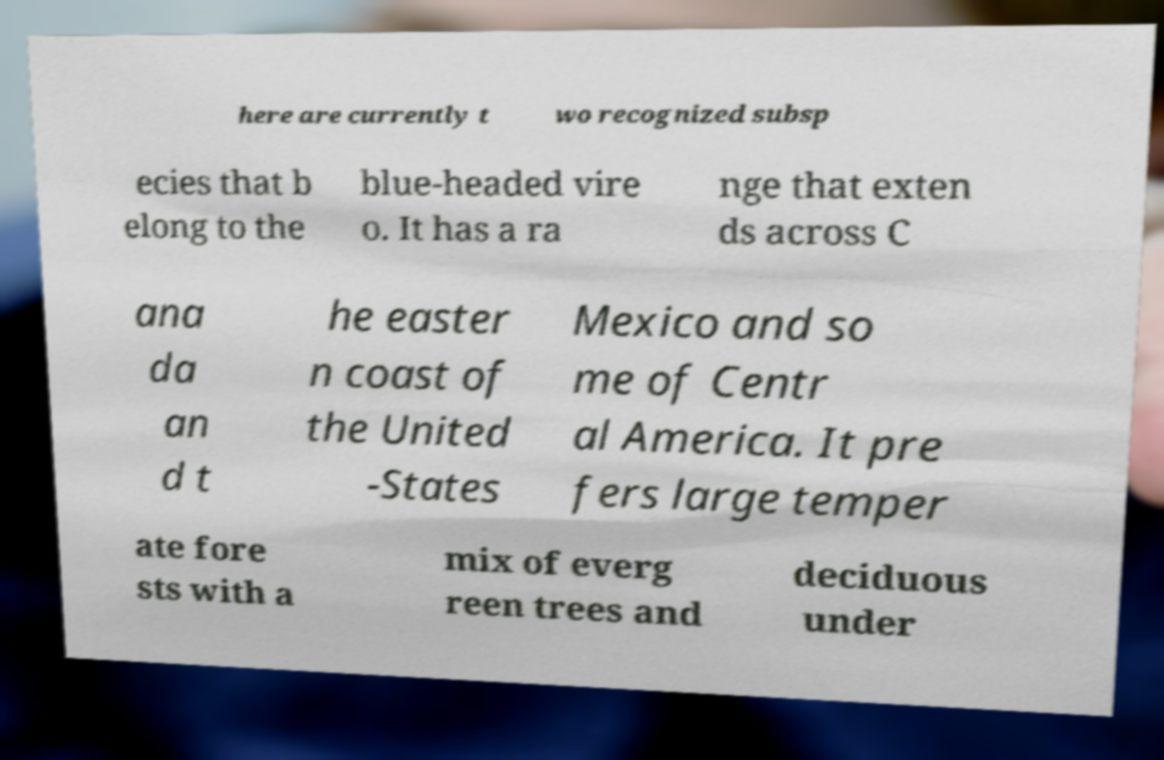I need the written content from this picture converted into text. Can you do that? here are currently t wo recognized subsp ecies that b elong to the blue-headed vire o. It has a ra nge that exten ds across C ana da an d t he easter n coast of the United -States Mexico and so me of Centr al America. It pre fers large temper ate fore sts with a mix of everg reen trees and deciduous under 